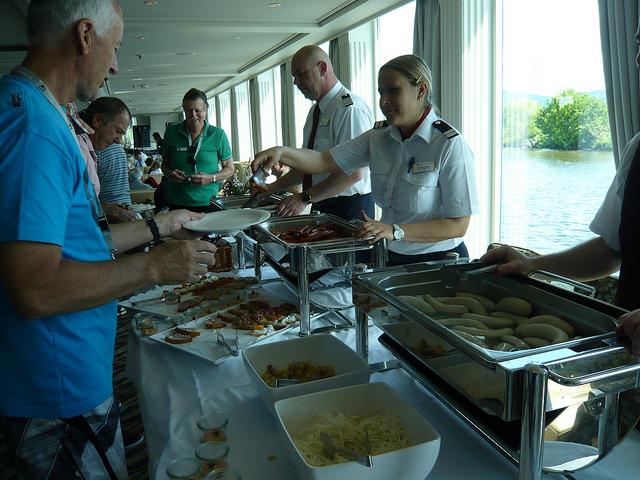Is the person in the blue shirt a teenager?
Quick response, please. No. Are there some sort of sausages in the pan?
Give a very brief answer. Yes. What hand does she have on the machine?
Quick response, please. Left. How many workers are there?
Keep it brief. 2. Is the man torturing the food by cooking it?
Write a very short answer. No. What room is shown?
Write a very short answer. Dining room. 